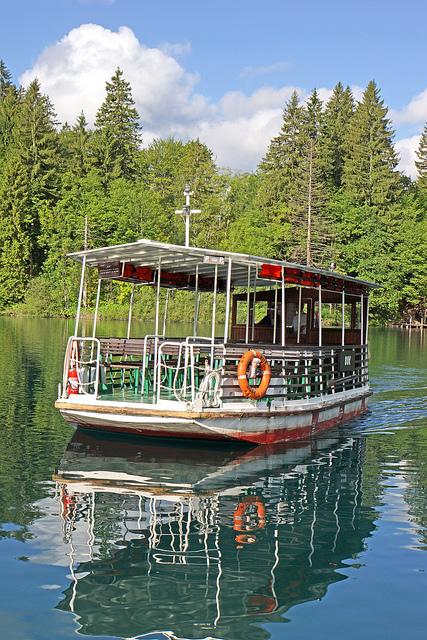What kind of boat is this?
Write a very short answer. Pontoon. What is the boat in?
Give a very brief answer. Water. How many people are there?
Quick response, please. 1. 